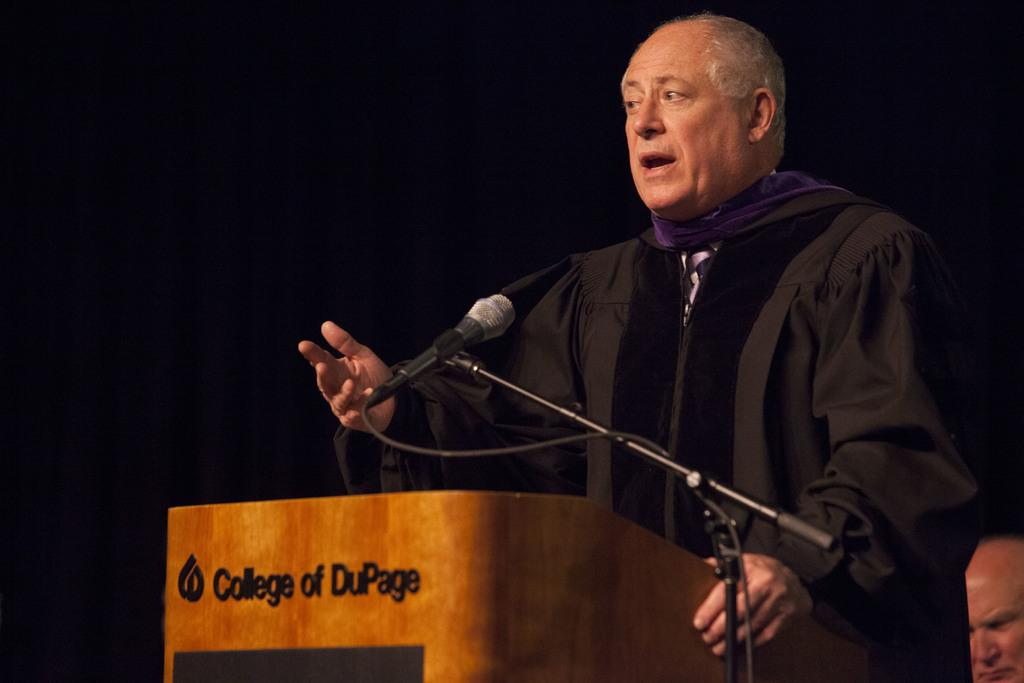What is the main subject of the image? There is a person standing in the image. What is the person wearing? The person is wearing a dress. What is in front of the person? There is a podium, a microphone, and a stand in front of the person. What is the color of the background in the image? The background of the image is black. What trick is the person performing with their elbow in the image? There is no trick or elbow movement depicted in the image; the person is simply standing in front of a podium. 